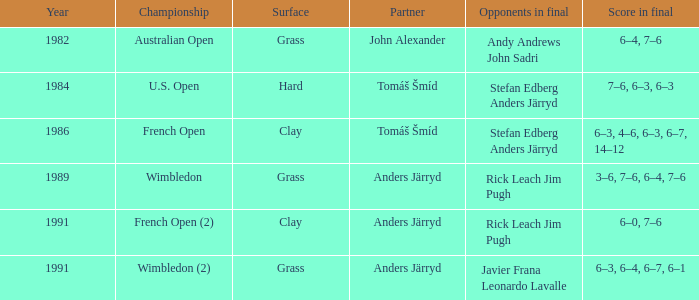Give me the full table as a dictionary. {'header': ['Year', 'Championship', 'Surface', 'Partner', 'Opponents in final', 'Score in final'], 'rows': [['1982', 'Australian Open', 'Grass', 'John Alexander', 'Andy Andrews John Sadri', '6–4, 7–6'], ['1984', 'U.S. Open', 'Hard', 'Tomáš Šmíd', 'Stefan Edberg Anders Järryd', '7–6, 6–3, 6–3'], ['1986', 'French Open', 'Clay', 'Tomáš Šmíd', 'Stefan Edberg Anders Järryd', '6–3, 4–6, 6–3, 6–7, 14–12'], ['1989', 'Wimbledon', 'Grass', 'Anders Järryd', 'Rick Leach Jim Pugh', '3–6, 7–6, 6–4, 7–6'], ['1991', 'French Open (2)', 'Clay', 'Anders Järryd', 'Rick Leach Jim Pugh', '6–0, 7–6'], ['1991', 'Wimbledon (2)', 'Grass', 'Anders Järryd', 'Javier Frana Leonardo Lavalle', '6–3, 6–4, 6–7, 6–1']]} Who was his associate in 1989? Anders Järryd. 